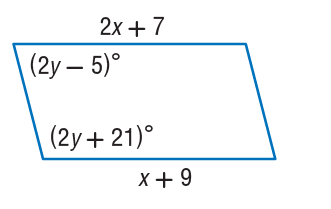Answer the mathemtical geometry problem and directly provide the correct option letter.
Question: Find x so that the quadrilateral is a parallelogram.
Choices: A: 2 B: 4 C: 9 D: 11 A 